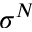<formula> <loc_0><loc_0><loc_500><loc_500>\sigma ^ { N }</formula> 